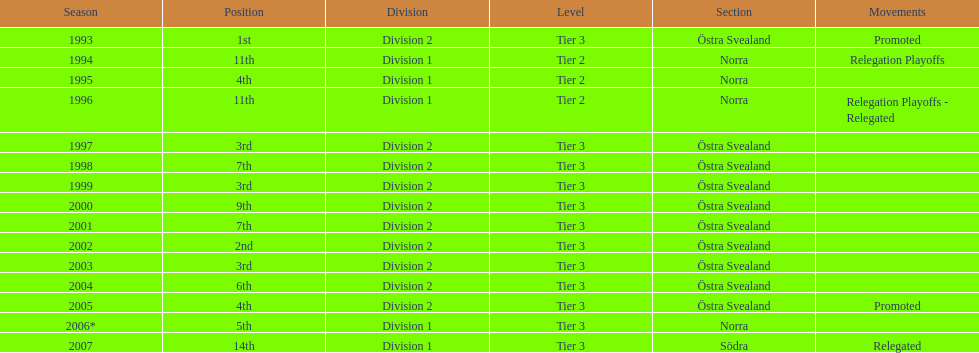They placed third in 2003. when did they place third before that? 1999. 